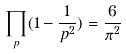Convert formula to latex. <formula><loc_0><loc_0><loc_500><loc_500>\prod _ { p } ( 1 - \frac { 1 } { p ^ { 2 } } ) = \frac { 6 } { \pi ^ { 2 } }</formula> 